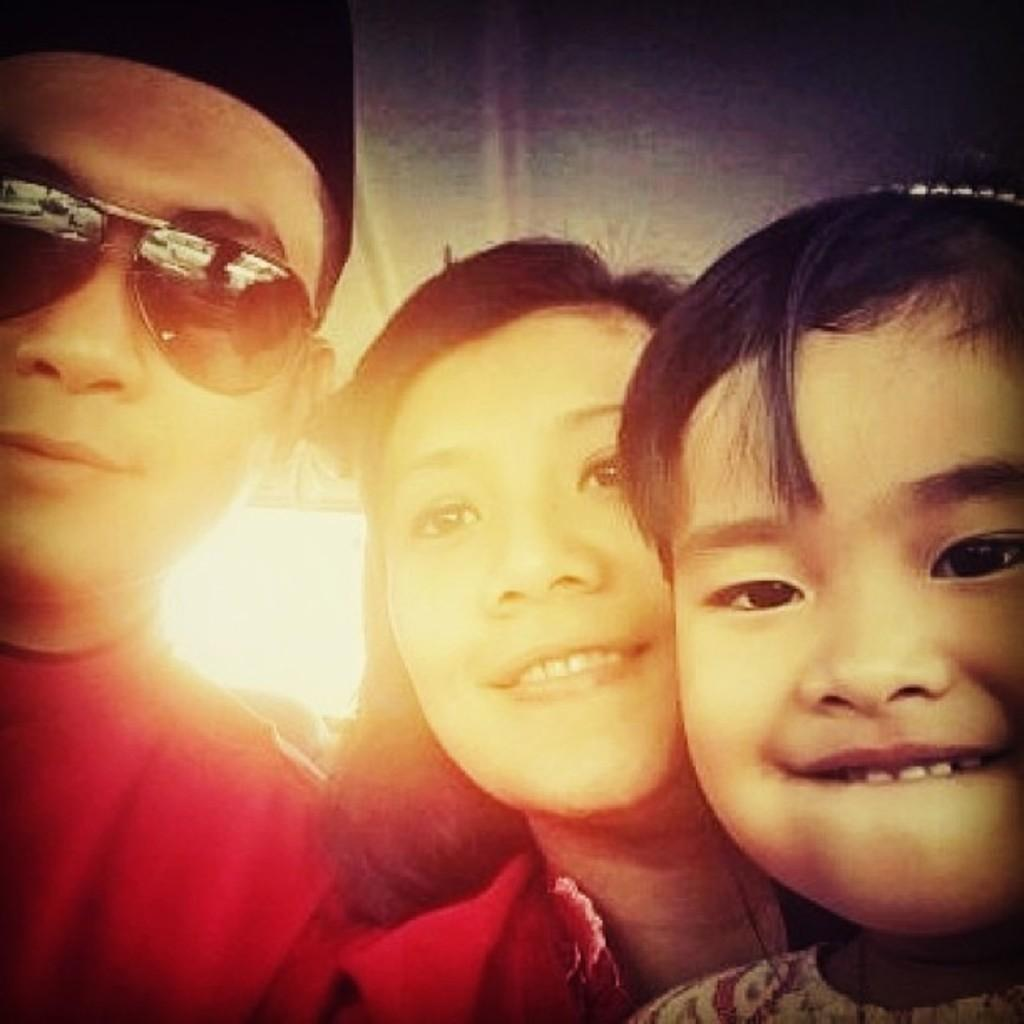How many people are present in the image? There are three people in the image: a man, a woman, and a kid. Can you describe the relationship between the people in the image? The facts provided do not give enough information to determine the relationship between the people in the image. What is the gender of the person in the middle of the image? The person in the middle of the image is a woman. What type of song is the kid singing in the image? There is no indication in the image that the kid is singing a song. 